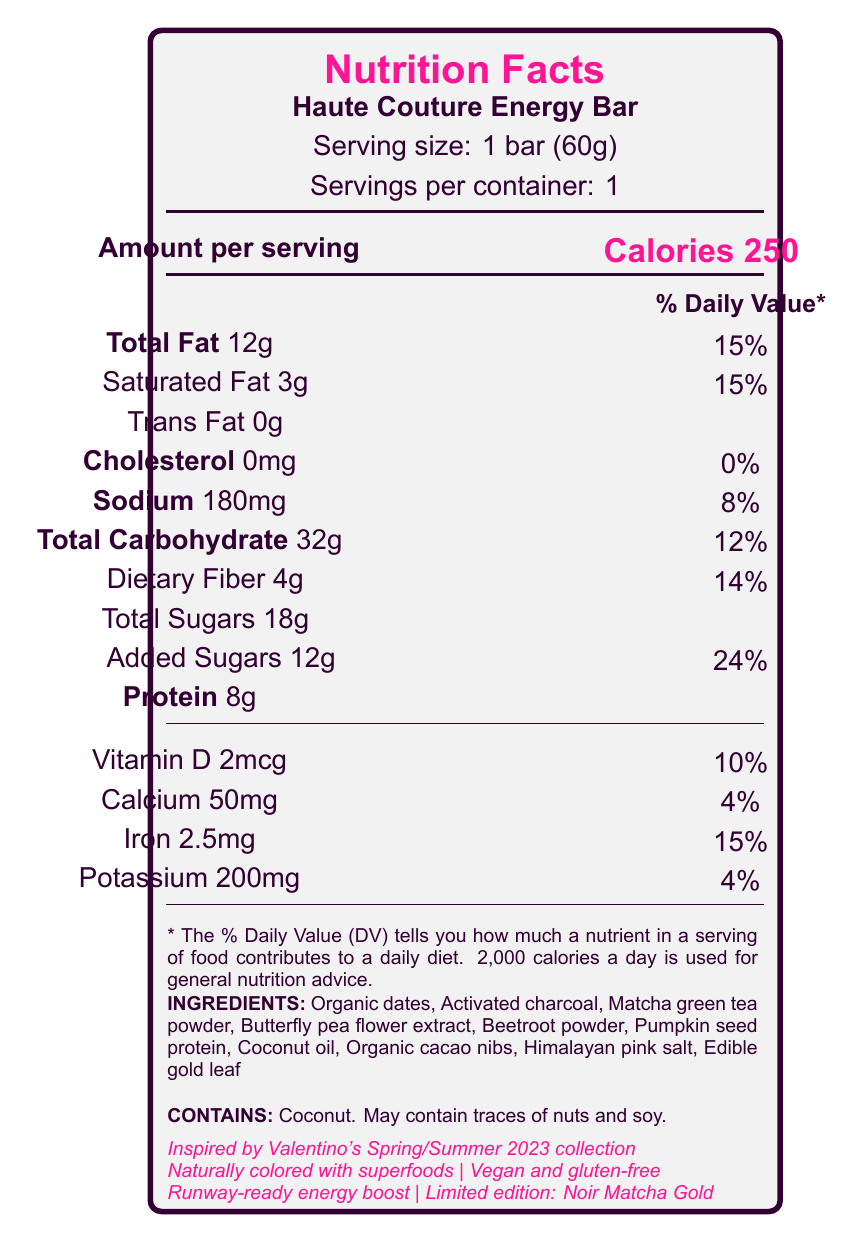what is the serving size? The serving size is explicitly mentioned as "1 bar (60g)" in the document.
Answer: 1 bar (60g) how many servings are in the container? The document states "Servings per container: 1", indicating that there is only one serving in the container.
Answer: 1 what is the calorie count per serving? The calorie count is clearly stated as "Calories 250" in the document.
Answer: 250 calories how much protein is in the Haute Couture Energy Bar? The document lists "Protein: 8g" under the nutritional information.
Answer: 8g what are the total carbohydrates in the bar? The total carbohydrate content is mentioned as "Total Carbohydrate: 32g".
Answer: 32g which vitamin has a 10% daily value? A. Vitamin A B. Vitamin C C. Vitamin D D. Calcium The document mentions "Vitamin D 2mcg", which corresponds to "10% daily value".
Answer: C. Vitamin D what is the serving size of the energy bar? A. 30g B. 50g C. 60g D. 100g The document specifies the serving size as "1 bar (60g)".
Answer: C. 60g what ingredient in the Haute Couture Energy Bar might trace amounts of nuts and soy? The document mentions the allergen information, including "Contains coconut" and "May contain traces of nuts and soy".
Answer: Coconut is the energy bar vegan? Under the marketing claims, the document states that the bar is "Vegan and gluten-free".
Answer: Yes describe the main idea of the Haute Couture Energy Bar's nutrition facts label The document includes nutritional details such as serving size, calorie count, and various macronutrients and micronutrients along with unique ingredients. Moreover, it mentions marketing claims that tie the product to high fashion, reflects on its potential health risks, and includes an endorsement by a celebrity.
Answer: The nutrition facts label of the Haute Couture Energy Bar provides detailed information about its serving size, calorie count, macronutrients, vitamins, minerals, ingredients, allergens, and unique marketing claims. The document highlights its unconventional ingredients inspired by fashion trends and its nutritional benefits, while also noting a controversy angle related to the use of activated charcoal. what is the controversy angle mentioned in the document? The document explicitly mentions the use of activated charcoal as potentially interfering with nutrient absorption and questions if fashion-forward eating is worth the potential health risks.
Answer: The use of activated charcoal, which may interfere with nutrient absorption. what collection inspired the Haute Couture Energy Bar? The document states that the energy bar is "Inspired by Valentino's Spring/Summer 2023 collection".
Answer: Valentino's Spring/Summer 2023 collection how many grams of dietary fiber does the energy bar contain? The document shows "Dietary Fiber: 4g".
Answer: 4g which ingredient is NOT listed in the document? A. Pumpkin seed protein B. Matcha green tea powder C. Almond butter D. Edible gold leaf The list of ingredients in the document includes Pumpkin seed protein, Matcha green tea powder, and Edible gold leaf, but not Almond butter.
Answer: C. Almond butter how much iron is in the bar as a percentage of the daily value? The document states "Iron 2.5mg" with a daily value of "15%".
Answer: 15% how much added sugar is in the energy bar? Added sugars are listed as "12g" with a daily value of "24%".
Answer: 12g how is the color of the bar achieved? The document claims that the bar is "Naturally colored with superfoods".
Answer: Naturally colored with superfoods who endorsed the Haute Couture Energy Bar at Paris Fashion Week? The document mentions that the energy bar was "Spotted in the hands of Lady Gaga at Paris Fashion Week".
Answer: Lady Gaga how many milligrams of potassium does the energy bar contain? The document lists "Potassium 200mg".
Answer: 200mg are there any trans fats in the Haute Couture Energy Bar? The document states "Trans Fat 0g".
Answer: No how much vitamin d is in the energy bar? The document specifies "Vitamin D 2mcg".
Answer: 2mcg is the Haute Couture Energy Bar gluten-free? The document includes "Vegan and gluten-free" in its marketing claims.
Answer: Yes what is the exact amount of cholesterol in the energy bar? The document states "Cholesterol 0mg".
Answer: 0mg how many calories are sourced from protein in the energy bar? The document provides the total calories and the amount of protein but does not break down the caloric value from each macronutrient source.
Answer: Not enough information 